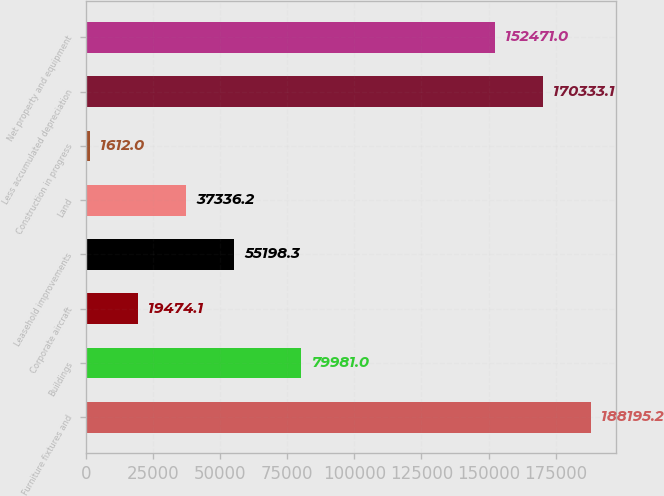Convert chart to OTSL. <chart><loc_0><loc_0><loc_500><loc_500><bar_chart><fcel>Furniture fixtures and<fcel>Buildings<fcel>Corporate aircraft<fcel>Leasehold improvements<fcel>Land<fcel>Construction in progress<fcel>Less accumulated depreciation<fcel>Net property and equipment<nl><fcel>188195<fcel>79981<fcel>19474.1<fcel>55198.3<fcel>37336.2<fcel>1612<fcel>170333<fcel>152471<nl></chart> 